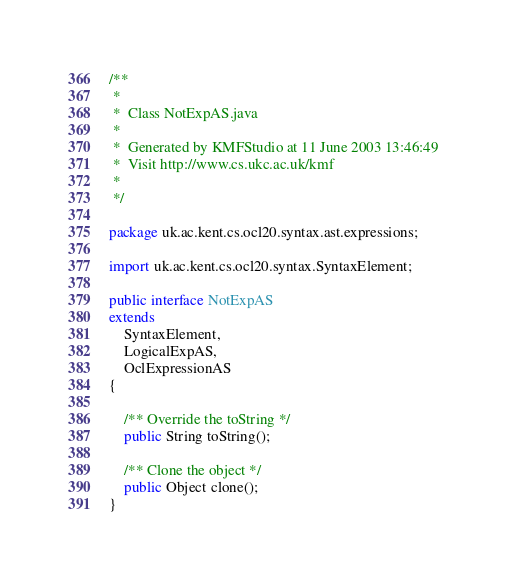<code> <loc_0><loc_0><loc_500><loc_500><_Java_>/**
 *
 *  Class NotExpAS.java
 *
 *  Generated by KMFStudio at 11 June 2003 13:46:49
 *  Visit http://www.cs.ukc.ac.uk/kmf
 *
 */

package uk.ac.kent.cs.ocl20.syntax.ast.expressions;

import uk.ac.kent.cs.ocl20.syntax.SyntaxElement;

public interface NotExpAS
extends
    SyntaxElement,
    LogicalExpAS,
    OclExpressionAS
{

	/** Override the toString */
	public String toString();

	/** Clone the object */
	public Object clone();
}
</code> 